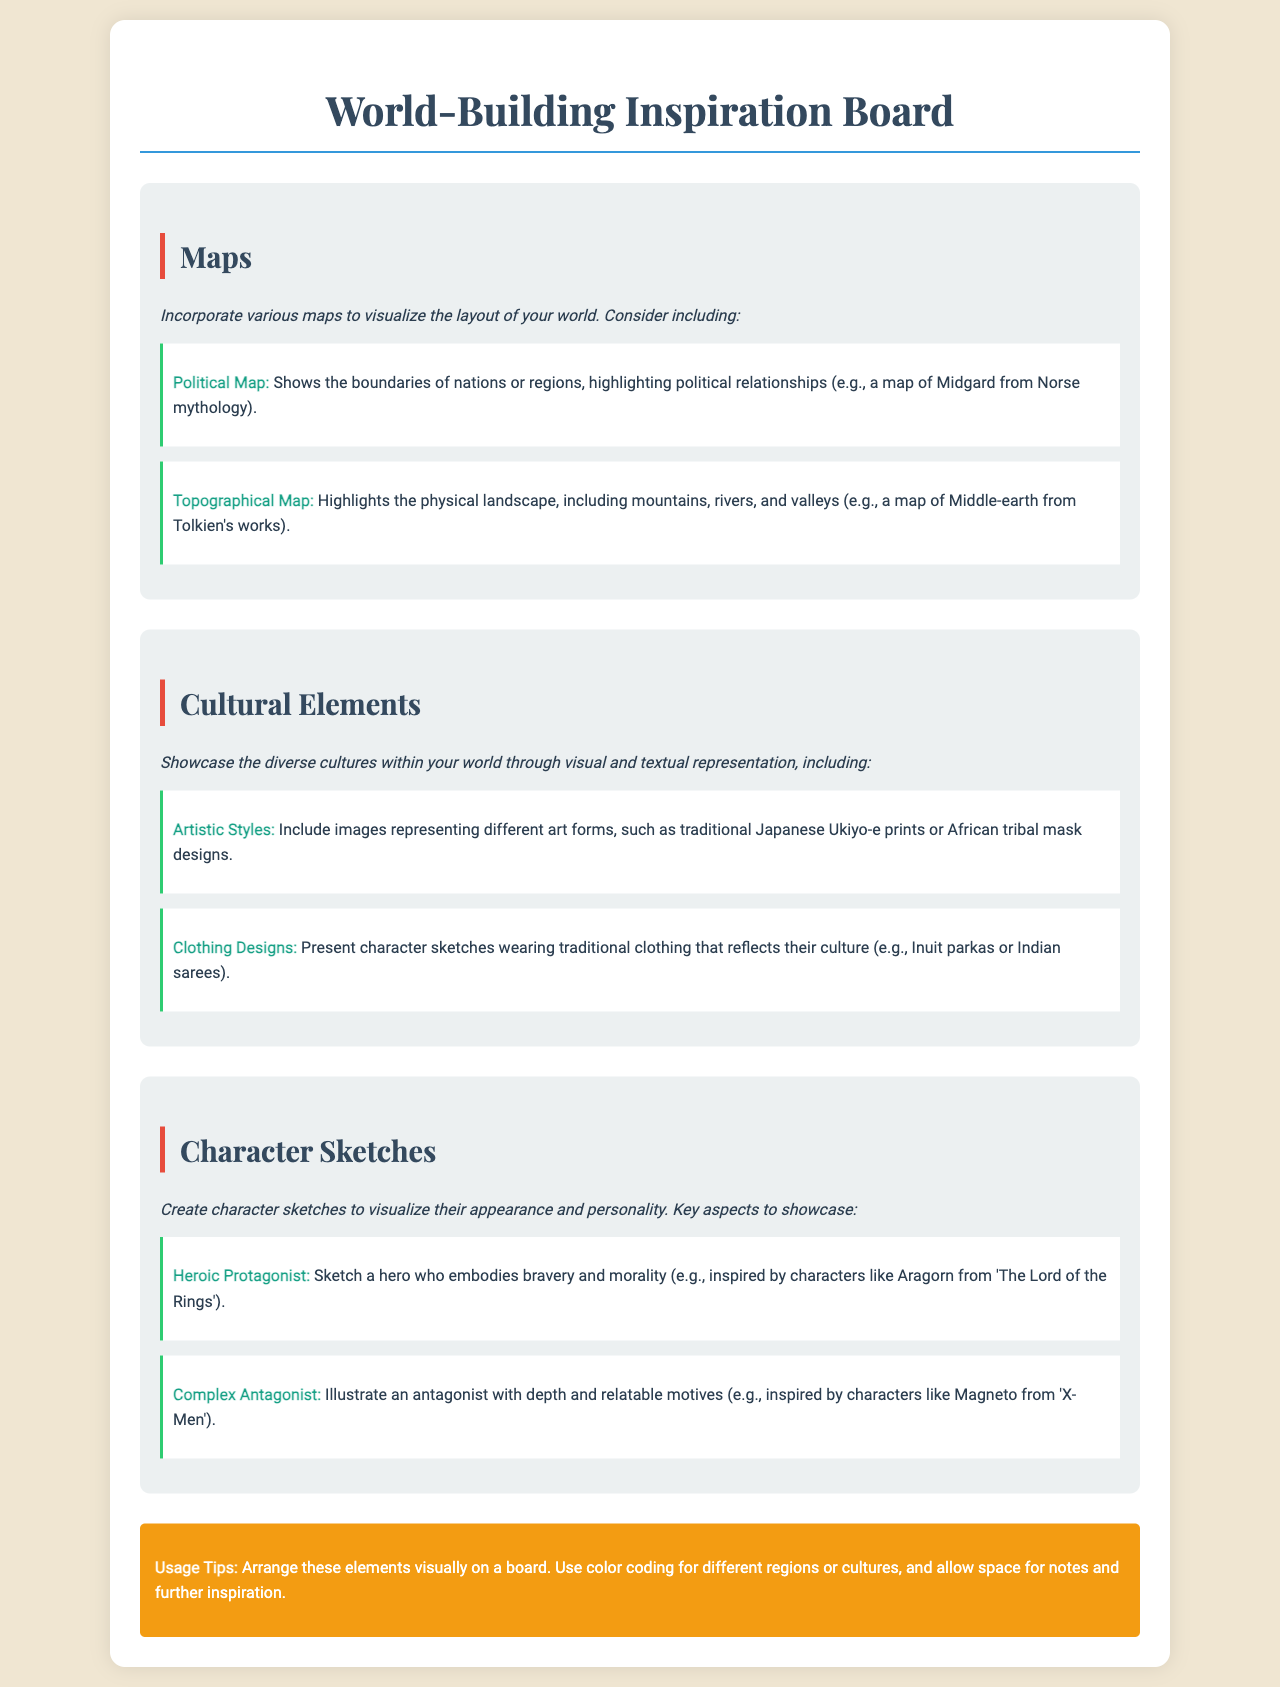What is the main title of the document? The main title is presented in a header format at the top of the document.
Answer: World-Building Inspiration Board What type of map shows political boundaries? The document categorizes types of maps, specifically outlining the nature of the political map.
Answer: Political Map Which cultural element includes representations of art forms? The section describes how to showcase different aspects of culture, mentioning artistic styles.
Answer: Artistic Styles Who is an example of a heroic protagonist? The section on character sketches illustrates examples, referencing a well-known character for inspiration.
Answer: Aragorn What color is used for the border of subsection headings? The document specifies color usage for visual elements, particularly in subsection headers.
Answer: Red How many types of maps are highlighted in the document? The section on maps specifies the different types, which can be counted based on the listings given.
Answer: Two What specific clothing is mentioned as an example of cultural representation? The document exemplifies types of clothing by referencing specific traditional attire within certain cultures.
Answer: Indian sarees What are the usage tips regarding the arrangement of elements? The document concludes with practical advice on layout decisions, which offers strategic direction for arranging components.
Answer: Color coding What is the main background color of the document? The overall design and aesthetic of the document feature a specified background color.
Answer: Light beige 